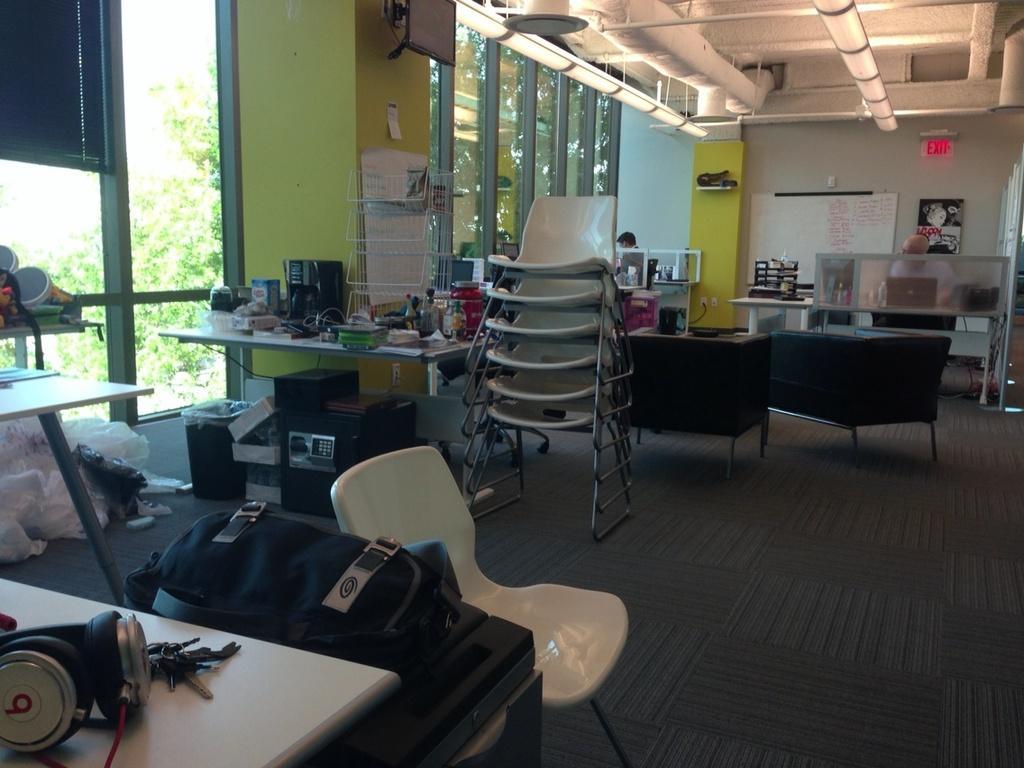Please provide a concise description of this image. In this room on the floor we can see chairs,tables,cloth,some other objects which are not very clear are on a table and there is a headset keychain on a platform. In the background there are few persons in cabins,a board and a frame on the wall,laptop on a platform and some other objects. Through the glass door we can see trees and sky. 